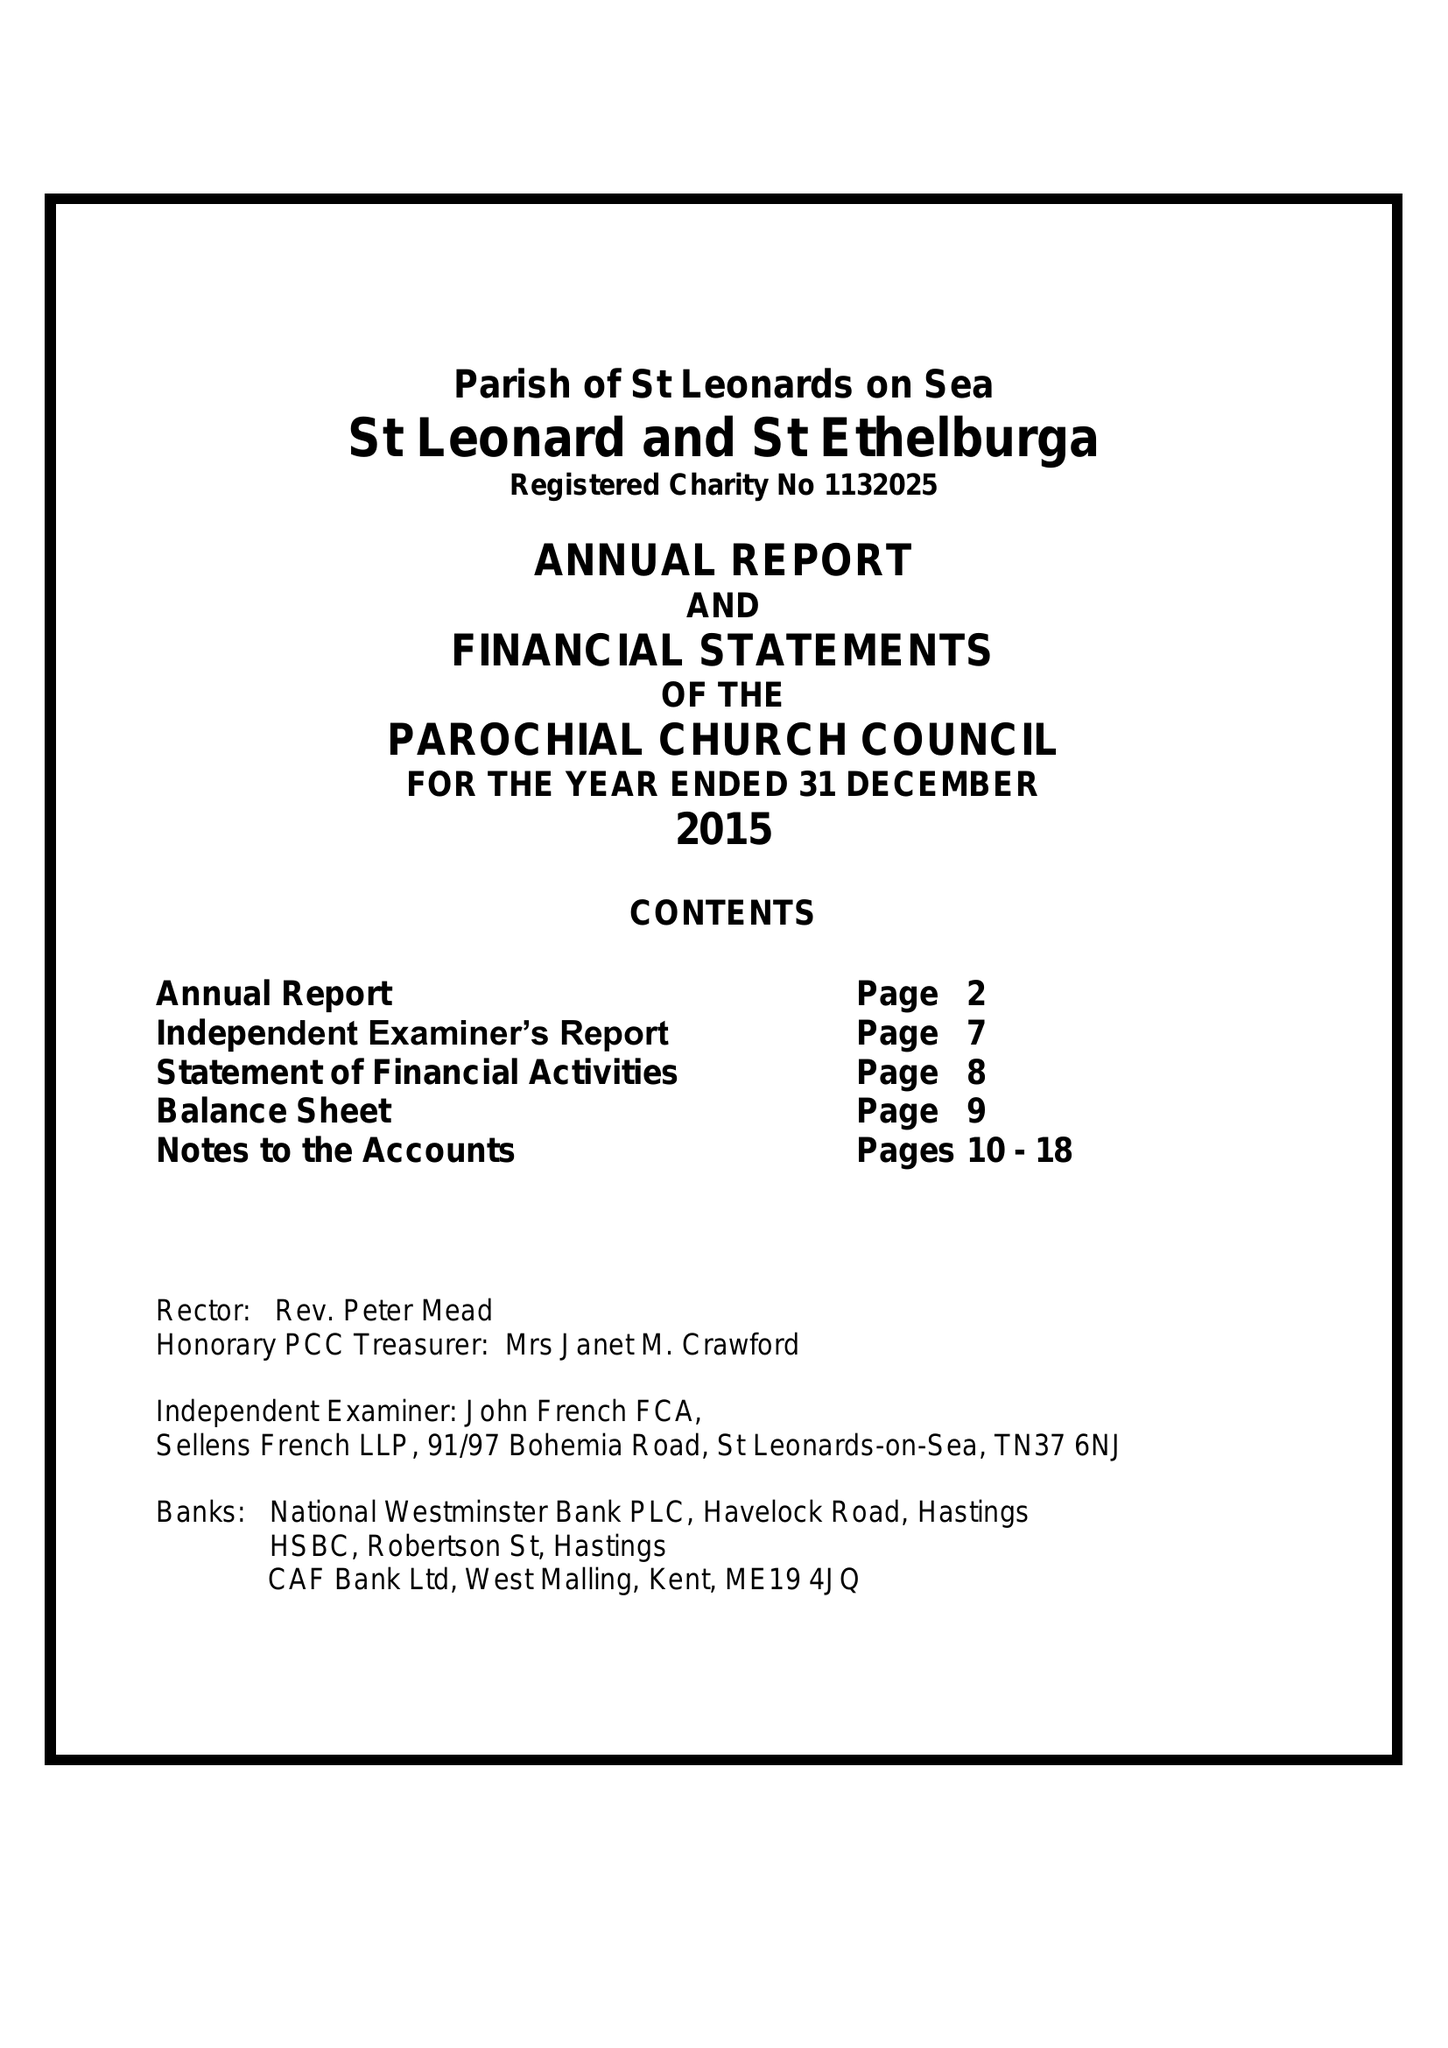What is the value for the charity_number?
Answer the question using a single word or phrase. 1132025 